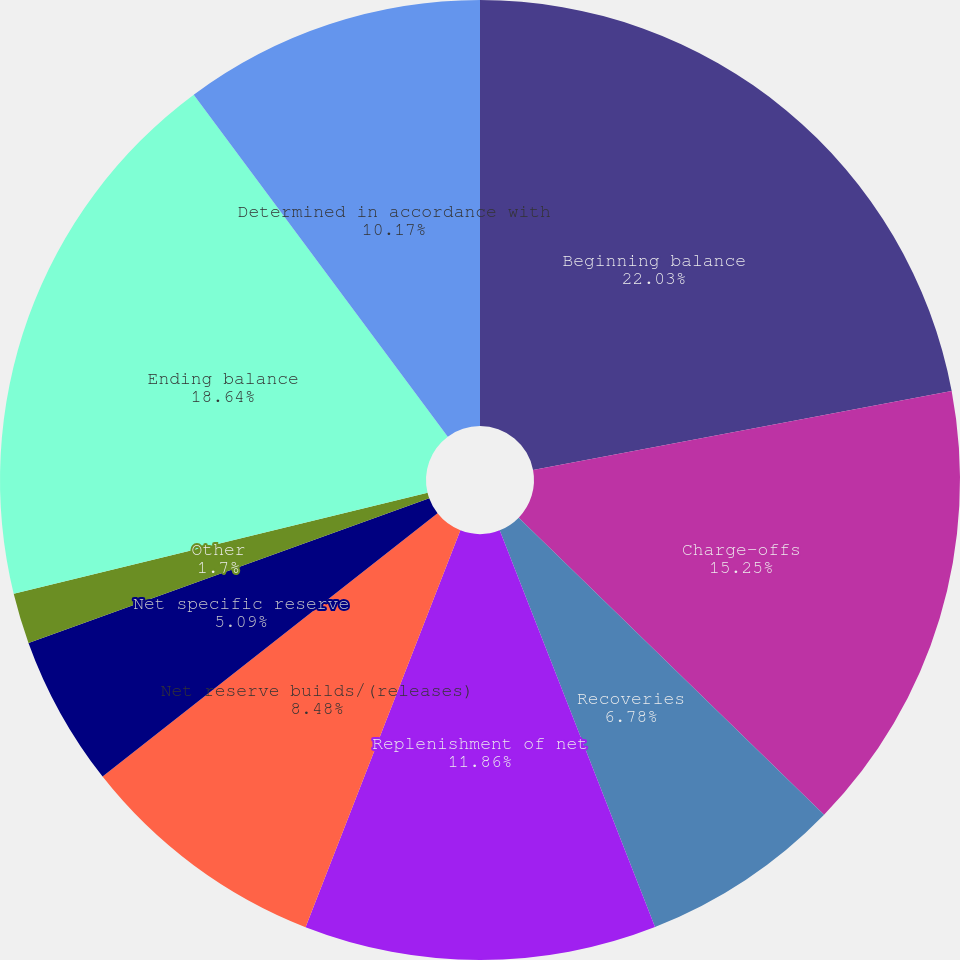Convert chart to OTSL. <chart><loc_0><loc_0><loc_500><loc_500><pie_chart><fcel>Beginning balance<fcel>Charge-offs<fcel>Recoveries<fcel>Replenishment of net<fcel>Net reserve builds/(releases)<fcel>Net specific reserve<fcel>Other<fcel>Ending balance<fcel>Determined in accordance with<nl><fcel>22.03%<fcel>15.25%<fcel>6.78%<fcel>11.86%<fcel>8.48%<fcel>5.09%<fcel>1.7%<fcel>18.64%<fcel>10.17%<nl></chart> 